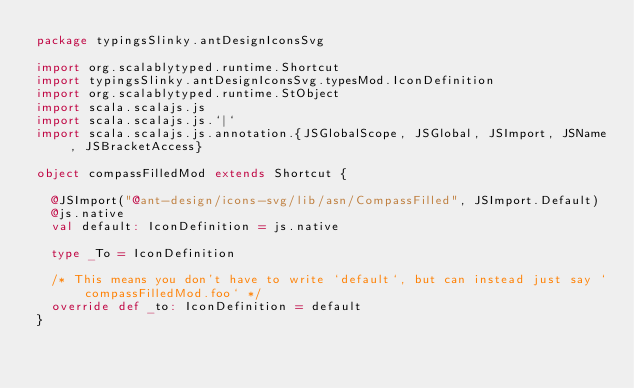<code> <loc_0><loc_0><loc_500><loc_500><_Scala_>package typingsSlinky.antDesignIconsSvg

import org.scalablytyped.runtime.Shortcut
import typingsSlinky.antDesignIconsSvg.typesMod.IconDefinition
import org.scalablytyped.runtime.StObject
import scala.scalajs.js
import scala.scalajs.js.`|`
import scala.scalajs.js.annotation.{JSGlobalScope, JSGlobal, JSImport, JSName, JSBracketAccess}

object compassFilledMod extends Shortcut {
  
  @JSImport("@ant-design/icons-svg/lib/asn/CompassFilled", JSImport.Default)
  @js.native
  val default: IconDefinition = js.native
  
  type _To = IconDefinition
  
  /* This means you don't have to write `default`, but can instead just say `compassFilledMod.foo` */
  override def _to: IconDefinition = default
}
</code> 